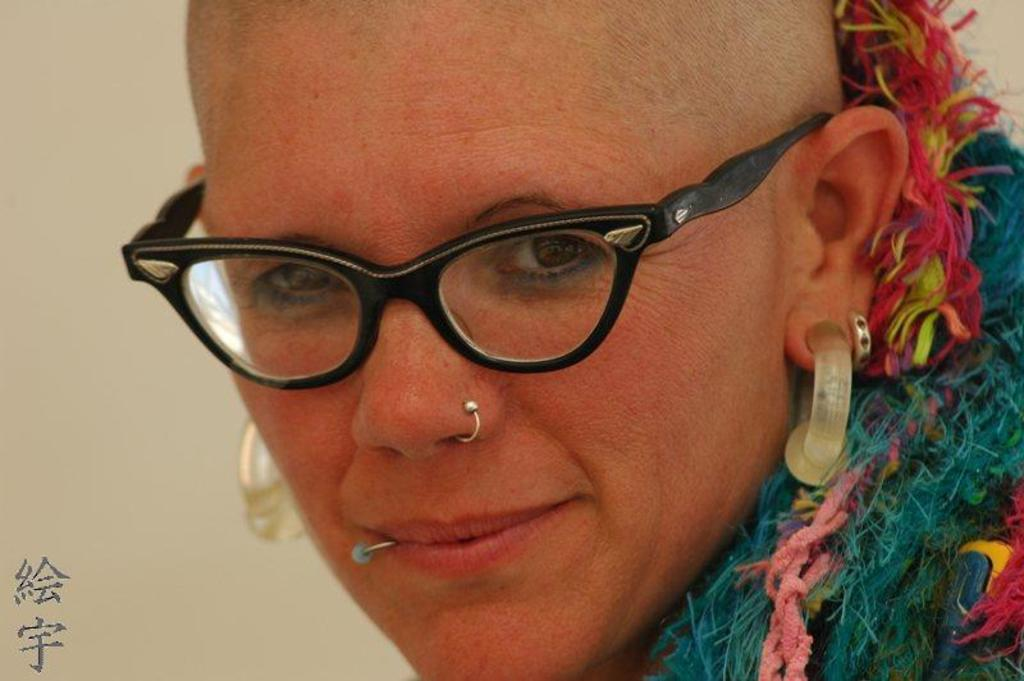Who is present in the image? There is a woman in the image. What is the woman wearing on her face? The woman is wearing spectacles. What type of jewelry is the woman wearing? The woman is wearing earrings. What color is the dress the woman is wearing? The woman is wearing a blue dress. What is the woman's facial expression? The woman is smiling. What is located beside the woman in the image? There is a wall beside the woman. Is there any text or logo visible in the image? Yes, there is a watermark in the bottom left corner of the image. Can you see any snow or horses in the image? No, there is no snow or horses present in the image. Is there a shelf visible in the image? No, there is no shelf visible in the image. 